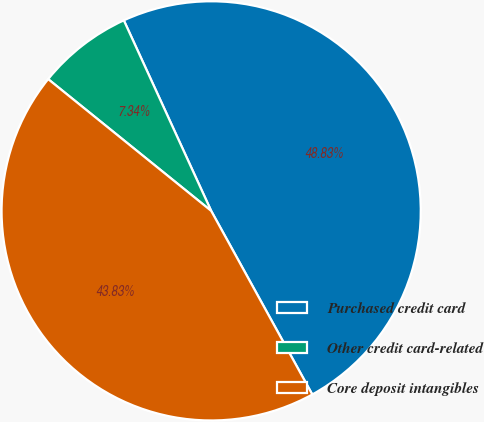Convert chart. <chart><loc_0><loc_0><loc_500><loc_500><pie_chart><fcel>Purchased credit card<fcel>Other credit card-related<fcel>Core deposit intangibles<nl><fcel>48.83%<fcel>7.34%<fcel>43.83%<nl></chart> 